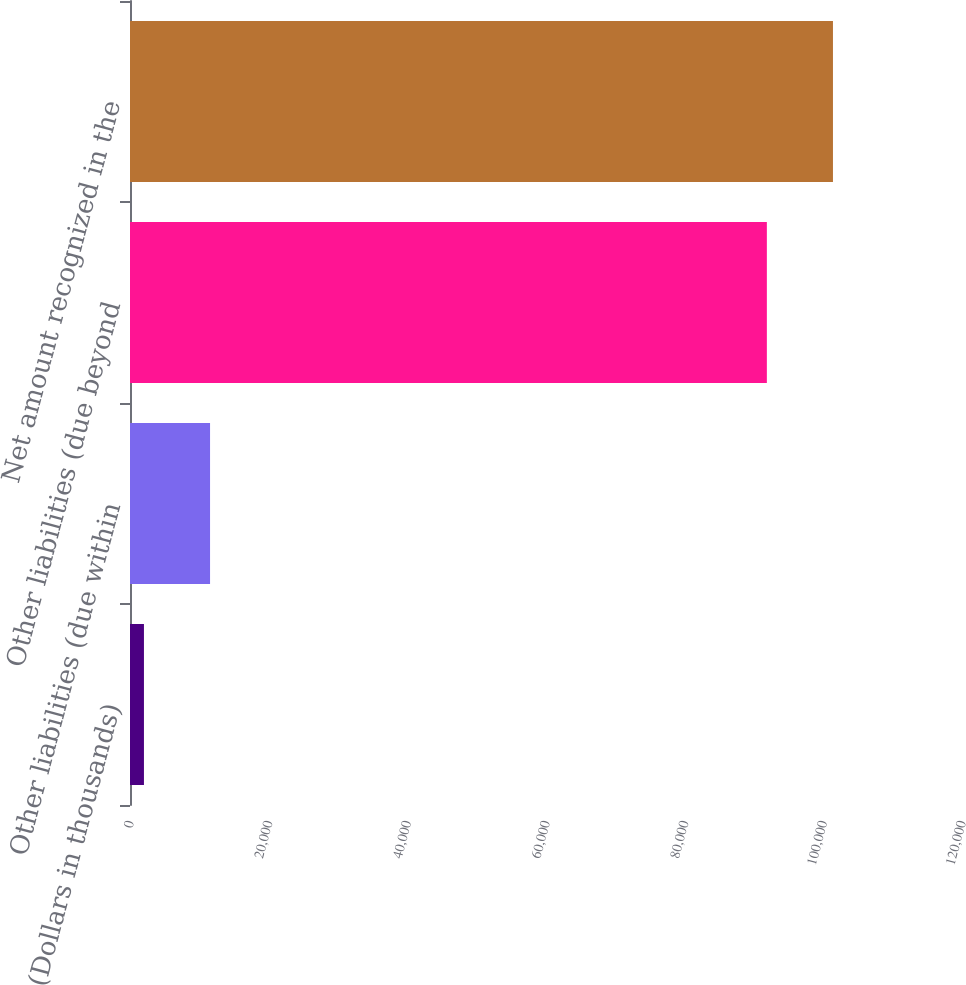Convert chart. <chart><loc_0><loc_0><loc_500><loc_500><bar_chart><fcel>(Dollars in thousands)<fcel>Other liabilities (due within<fcel>Other liabilities (due beyond<fcel>Net amount recognized in the<nl><fcel>2012<fcel>11546<fcel>91855<fcel>101389<nl></chart> 